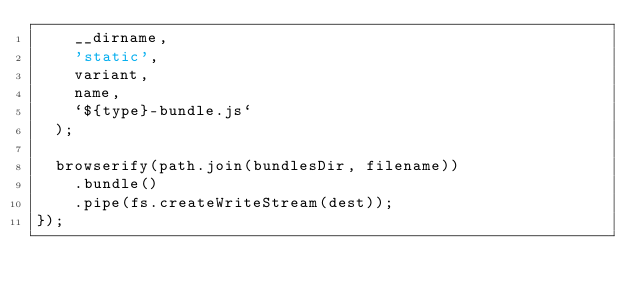<code> <loc_0><loc_0><loc_500><loc_500><_JavaScript_>    __dirname,
    'static',
    variant,
    name,
    `${type}-bundle.js`
  );

  browserify(path.join(bundlesDir, filename))
    .bundle()
    .pipe(fs.createWriteStream(dest));
});
</code> 